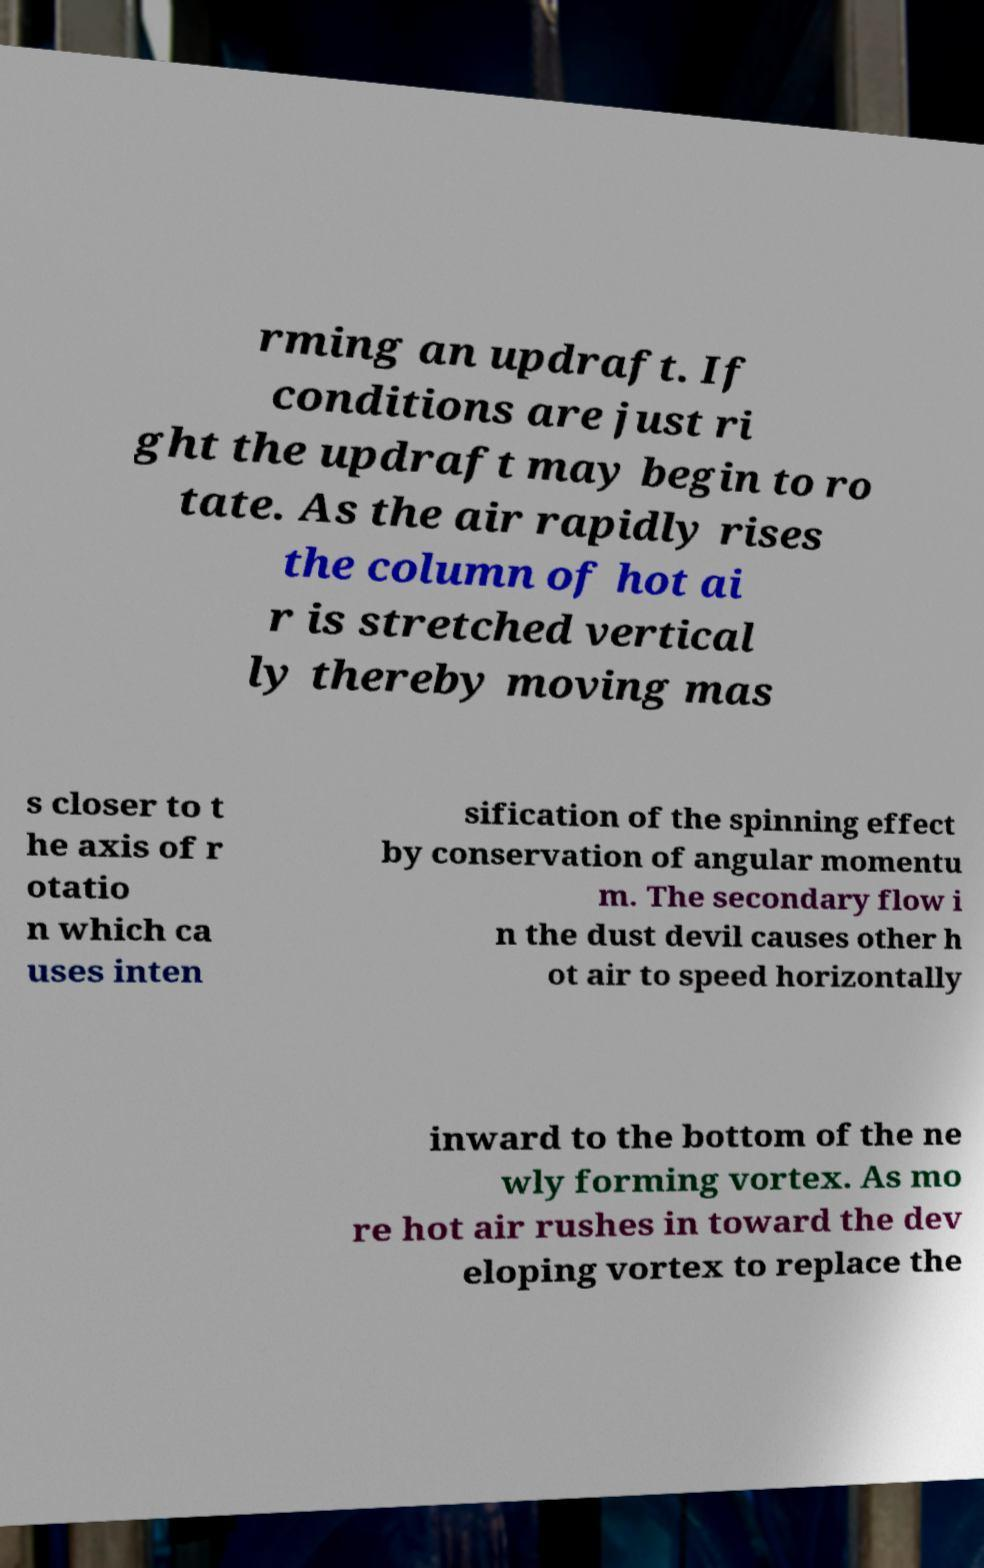There's text embedded in this image that I need extracted. Can you transcribe it verbatim? rming an updraft. If conditions are just ri ght the updraft may begin to ro tate. As the air rapidly rises the column of hot ai r is stretched vertical ly thereby moving mas s closer to t he axis of r otatio n which ca uses inten sification of the spinning effect by conservation of angular momentu m. The secondary flow i n the dust devil causes other h ot air to speed horizontally inward to the bottom of the ne wly forming vortex. As mo re hot air rushes in toward the dev eloping vortex to replace the 